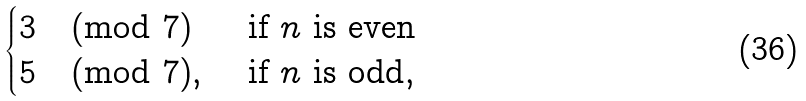<formula> <loc_0><loc_0><loc_500><loc_500>\begin{cases} 3 \pmod { 7 } & \text { if } n \text { is even} \\ 5 \pmod { 7 } , & \text { if } n \text { is odd} , \end{cases}</formula> 